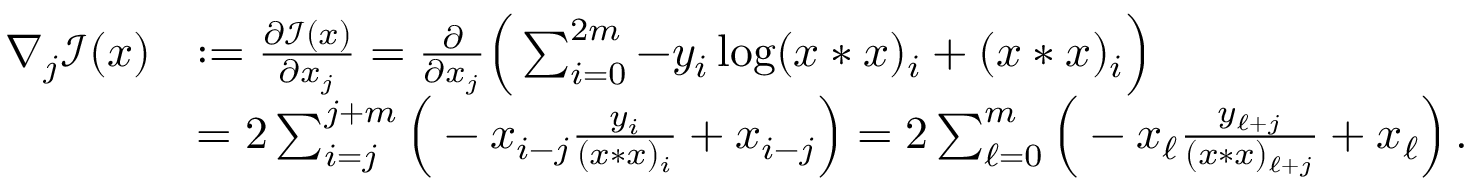<formula> <loc_0><loc_0><loc_500><loc_500>\begin{array} { r l } { \nabla _ { j } \mathcal { I } ( x ) } & { \colon = \frac { \partial \mathcal { I } ( x ) } { \partial x _ { j } } = \frac { \partial } { \partial x _ { j } } \left ( \sum _ { i = 0 } ^ { 2 m } - y _ { i } \log ( x * x ) _ { i } + ( x * x ) _ { i } \right ) } \\ & { = 2 \sum _ { i = j } ^ { j + m } \left ( - x _ { i - j } \frac { y _ { i } } { ( x * x ) _ { i } } + x _ { i - j } \right ) = 2 \sum _ { \ell = 0 } ^ { m } \left ( - x _ { \ell } \frac { y _ { \ell + j } } { ( x * x ) _ { \ell + j } } + x _ { \ell } \right ) \, . } \end{array}</formula> 